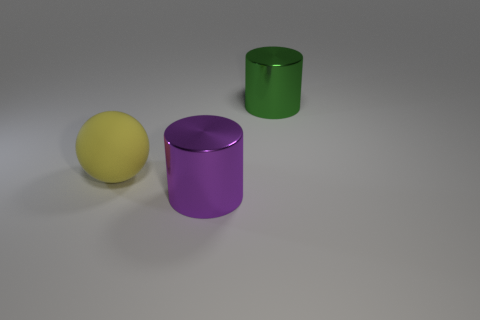Add 1 rubber spheres. How many objects exist? 4 Subtract all spheres. How many objects are left? 2 Add 3 red rubber blocks. How many red rubber blocks exist? 3 Subtract 1 yellow balls. How many objects are left? 2 Subtract all balls. Subtract all metal objects. How many objects are left? 0 Add 3 shiny things. How many shiny things are left? 5 